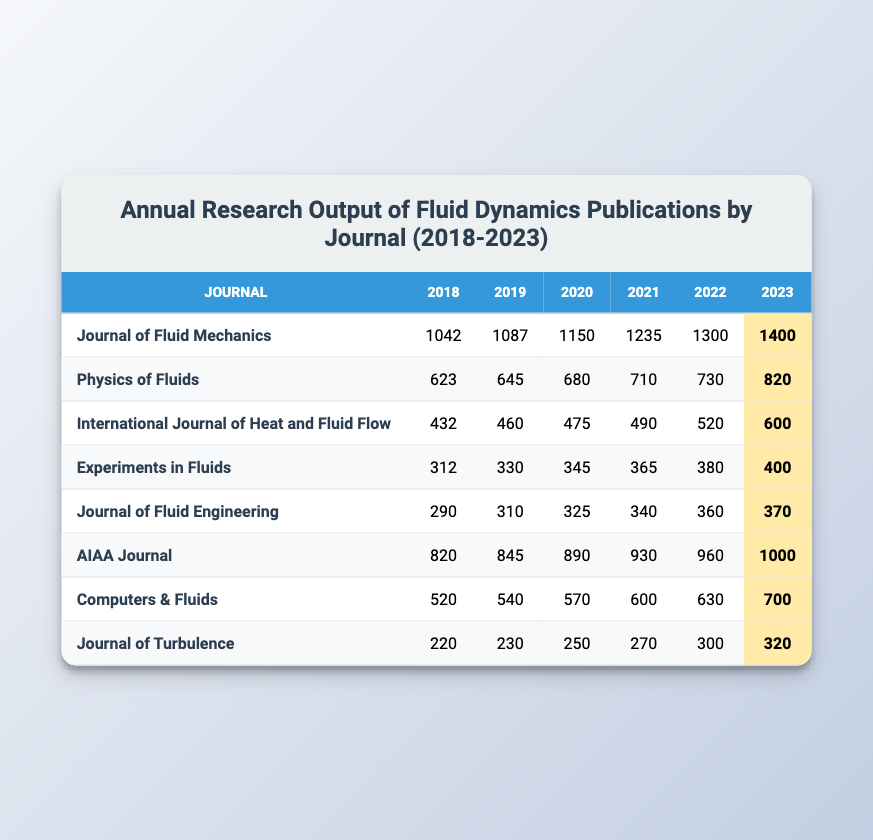What is the highest annual publication output in 2023? The highest value in the 2023 column is found in the "Journal of Fluid Mechanics," which has an output of 1400 publications.
Answer: 1400 Which journal saw the smallest number of publications in 2019? By examining the 2019 column, "Journal of Fluid Engineering" has the smallest output with 310 publications compared to the other journals listed.
Answer: 310 What was the overall increase in publications from 2018 to 2022 for the "AIAA Journal"? To find the increase, subtract the 2018 output (820) from the 2022 output (960). The difference is 960 - 820 = 140.
Answer: 140 Did the "International Journal of Heat and Fluid Flow" see an increase in publications every year from 2018 to 2023? Analyzing the data, this journal's output increased each year: 432 to 460 to 475 and so on until 600 in 2023, confirming a consistent rise.
Answer: Yes What is the total number of publications across all journals in 2021? To find the total for 2021, add all the values for that year: 1235 + 710 + 490 + 365 + 340 + 930 + 600 + 270 = 4640.
Answer: 4640 Which journal had the lowest total publication output over the years 2018 to 2023? By summing the publications for each journal, "Journal of Turbulence" has the lowest total of 220 + 230 + 250 + 270 + 300 + 320 = 1590.
Answer: Journal of Turbulence What was the average number of publications per year for "Computers & Fluids" from 2018 to 2023? To find the average, sum the publications for the years: 520 + 540 + 570 + 600 + 630 + 700 = 3960, then divide by 6 (years): 3960 / 6 = 660.
Answer: 660 In which year did "Experiments in Fluids" reach 365 publications? Referring to the table, "Experiments in Fluids" reached 365 publications in the year 2021.
Answer: 2021 Is there a journal that has had more than 1000 publications in 2023? Checking the 2023 column, both "Journal of Fluid Mechanics" (1400) and "AIAA Journal" (1000) have more than 1000 publications, confirming that there are journals meeting this criteria.
Answer: Yes What was the percentage increase in publications for "Physical of Fluids" from 2018 to 2023? First, calculate the increase: 820 - 623 = 197. Next, find the percentage increase: (197 / 623) * 100 ≈ 31.6%.
Answer: 31.6% How many more publications did "Journal of Fluid Mechanics" have compared to "Physics of Fluids" in 2022? For 2022, "Journal of Fluid Mechanics" had 1300 and "Physics of Fluids" had 730. Subtracting gives: 1300 - 730 = 570.
Answer: 570 